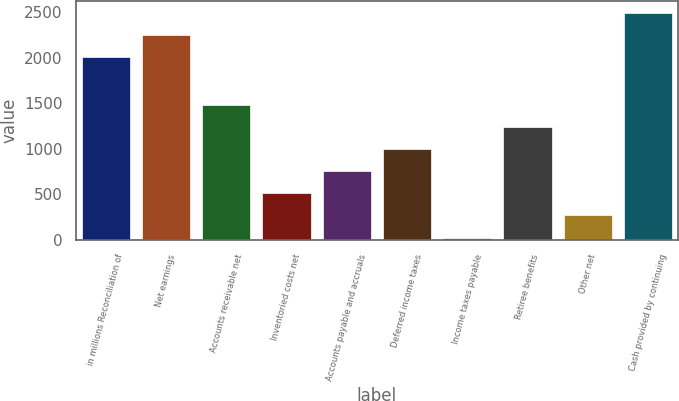Convert chart. <chart><loc_0><loc_0><loc_500><loc_500><bar_chart><fcel>in millions Reconciliation of<fcel>Net earnings<fcel>Accounts receivable net<fcel>Inventoried costs net<fcel>Accounts payable and accruals<fcel>Deferred income taxes<fcel>Income taxes payable<fcel>Retiree benefits<fcel>Other net<fcel>Cash provided by continuing<nl><fcel>2010<fcel>2252.7<fcel>1482.2<fcel>511.4<fcel>754.1<fcel>996.8<fcel>26<fcel>1239.5<fcel>268.7<fcel>2495.4<nl></chart> 